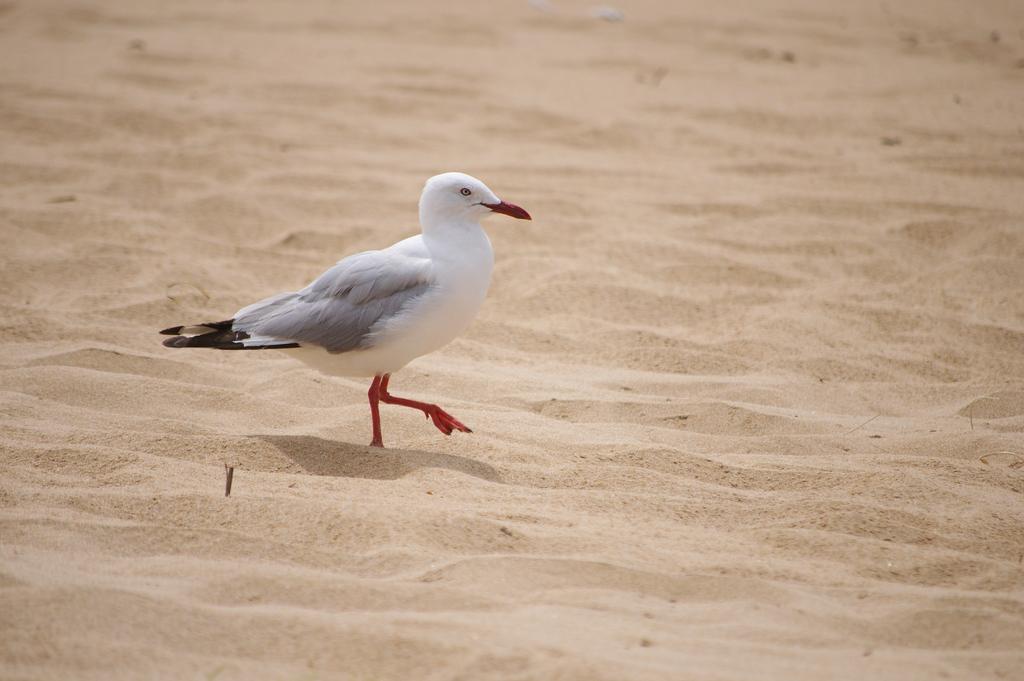How would you summarize this image in a sentence or two? In this image we can see a bird standing on the sand. 